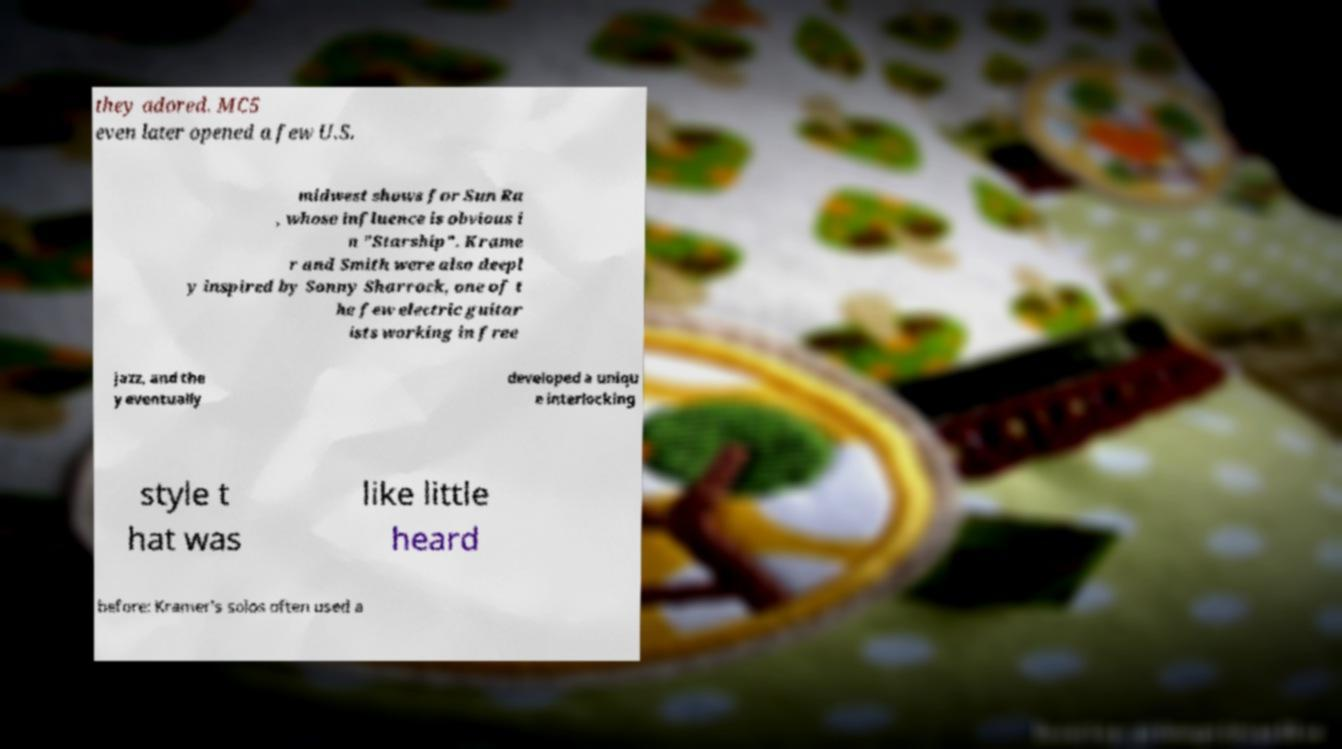There's text embedded in this image that I need extracted. Can you transcribe it verbatim? they adored. MC5 even later opened a few U.S. midwest shows for Sun Ra , whose influence is obvious i n "Starship". Krame r and Smith were also deepl y inspired by Sonny Sharrock, one of t he few electric guitar ists working in free jazz, and the y eventually developed a uniqu e interlocking style t hat was like little heard before: Kramer's solos often used a 